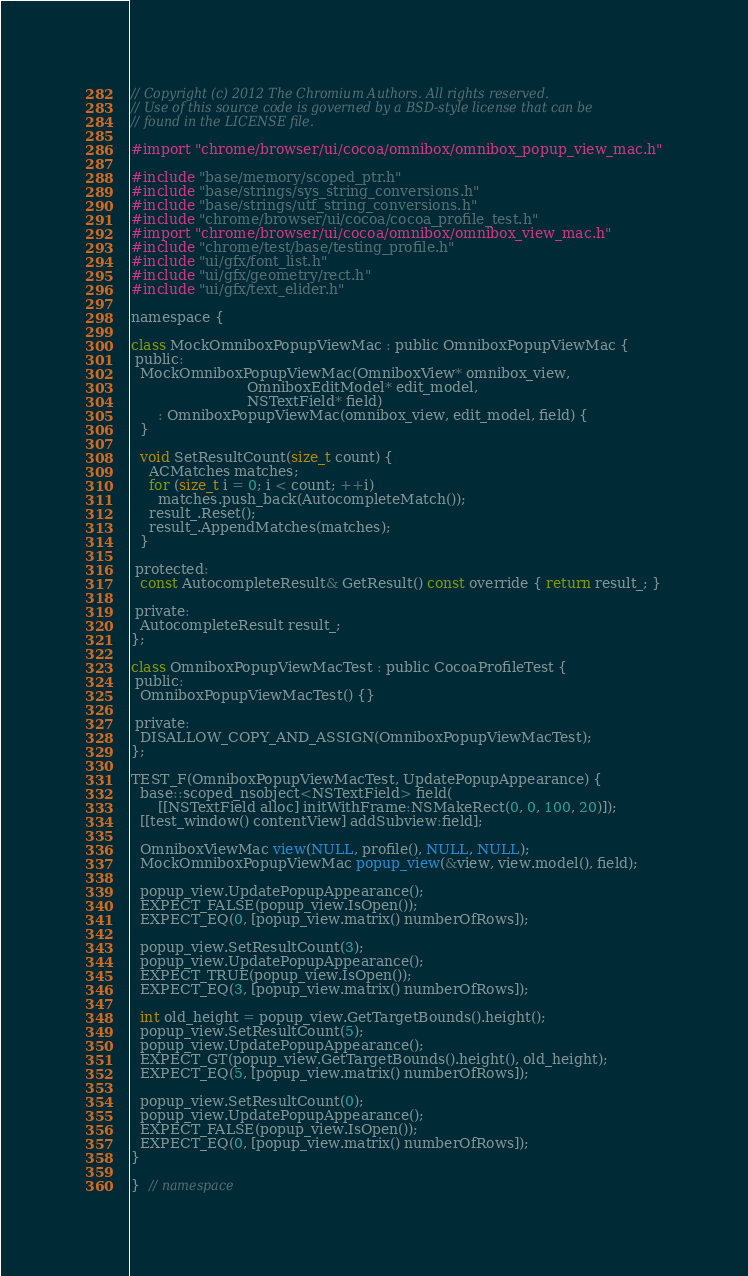<code> <loc_0><loc_0><loc_500><loc_500><_ObjectiveC_>// Copyright (c) 2012 The Chromium Authors. All rights reserved.
// Use of this source code is governed by a BSD-style license that can be
// found in the LICENSE file.

#import "chrome/browser/ui/cocoa/omnibox/omnibox_popup_view_mac.h"

#include "base/memory/scoped_ptr.h"
#include "base/strings/sys_string_conversions.h"
#include "base/strings/utf_string_conversions.h"
#include "chrome/browser/ui/cocoa/cocoa_profile_test.h"
#import "chrome/browser/ui/cocoa/omnibox/omnibox_view_mac.h"
#include "chrome/test/base/testing_profile.h"
#include "ui/gfx/font_list.h"
#include "ui/gfx/geometry/rect.h"
#include "ui/gfx/text_elider.h"

namespace {

class MockOmniboxPopupViewMac : public OmniboxPopupViewMac {
 public:
  MockOmniboxPopupViewMac(OmniboxView* omnibox_view,
                          OmniboxEditModel* edit_model,
                          NSTextField* field)
      : OmniboxPopupViewMac(omnibox_view, edit_model, field) {
  }

  void SetResultCount(size_t count) {
    ACMatches matches;
    for (size_t i = 0; i < count; ++i)
      matches.push_back(AutocompleteMatch());
    result_.Reset();
    result_.AppendMatches(matches);
  }

 protected:
  const AutocompleteResult& GetResult() const override { return result_; }

 private:
  AutocompleteResult result_;
};

class OmniboxPopupViewMacTest : public CocoaProfileTest {
 public:
  OmniboxPopupViewMacTest() {}

 private:
  DISALLOW_COPY_AND_ASSIGN(OmniboxPopupViewMacTest);
};

TEST_F(OmniboxPopupViewMacTest, UpdatePopupAppearance) {
  base::scoped_nsobject<NSTextField> field(
      [[NSTextField alloc] initWithFrame:NSMakeRect(0, 0, 100, 20)]);
  [[test_window() contentView] addSubview:field];

  OmniboxViewMac view(NULL, profile(), NULL, NULL);
  MockOmniboxPopupViewMac popup_view(&view, view.model(), field);

  popup_view.UpdatePopupAppearance();
  EXPECT_FALSE(popup_view.IsOpen());
  EXPECT_EQ(0, [popup_view.matrix() numberOfRows]);

  popup_view.SetResultCount(3);
  popup_view.UpdatePopupAppearance();
  EXPECT_TRUE(popup_view.IsOpen());
  EXPECT_EQ(3, [popup_view.matrix() numberOfRows]);

  int old_height = popup_view.GetTargetBounds().height();
  popup_view.SetResultCount(5);
  popup_view.UpdatePopupAppearance();
  EXPECT_GT(popup_view.GetTargetBounds().height(), old_height);
  EXPECT_EQ(5, [popup_view.matrix() numberOfRows]);

  popup_view.SetResultCount(0);
  popup_view.UpdatePopupAppearance();
  EXPECT_FALSE(popup_view.IsOpen());
  EXPECT_EQ(0, [popup_view.matrix() numberOfRows]);
}

}  // namespace
</code> 